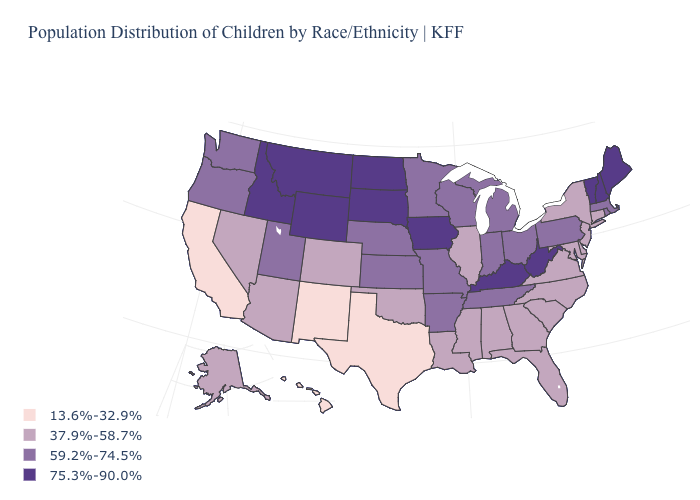Does West Virginia have the highest value in the USA?
Answer briefly. Yes. Does the first symbol in the legend represent the smallest category?
Answer briefly. Yes. What is the value of Illinois?
Keep it brief. 37.9%-58.7%. What is the highest value in the West ?
Answer briefly. 75.3%-90.0%. What is the highest value in the USA?
Answer briefly. 75.3%-90.0%. What is the highest value in the USA?
Short answer required. 75.3%-90.0%. Among the states that border Kentucky , which have the highest value?
Answer briefly. West Virginia. What is the value of Maryland?
Keep it brief. 37.9%-58.7%. Name the states that have a value in the range 75.3%-90.0%?
Answer briefly. Idaho, Iowa, Kentucky, Maine, Montana, New Hampshire, North Dakota, South Dakota, Vermont, West Virginia, Wyoming. What is the value of Louisiana?
Concise answer only. 37.9%-58.7%. What is the value of Utah?
Be succinct. 59.2%-74.5%. What is the value of North Dakota?
Answer briefly. 75.3%-90.0%. Does the first symbol in the legend represent the smallest category?
Be succinct. Yes. Does the first symbol in the legend represent the smallest category?
Keep it brief. Yes. 